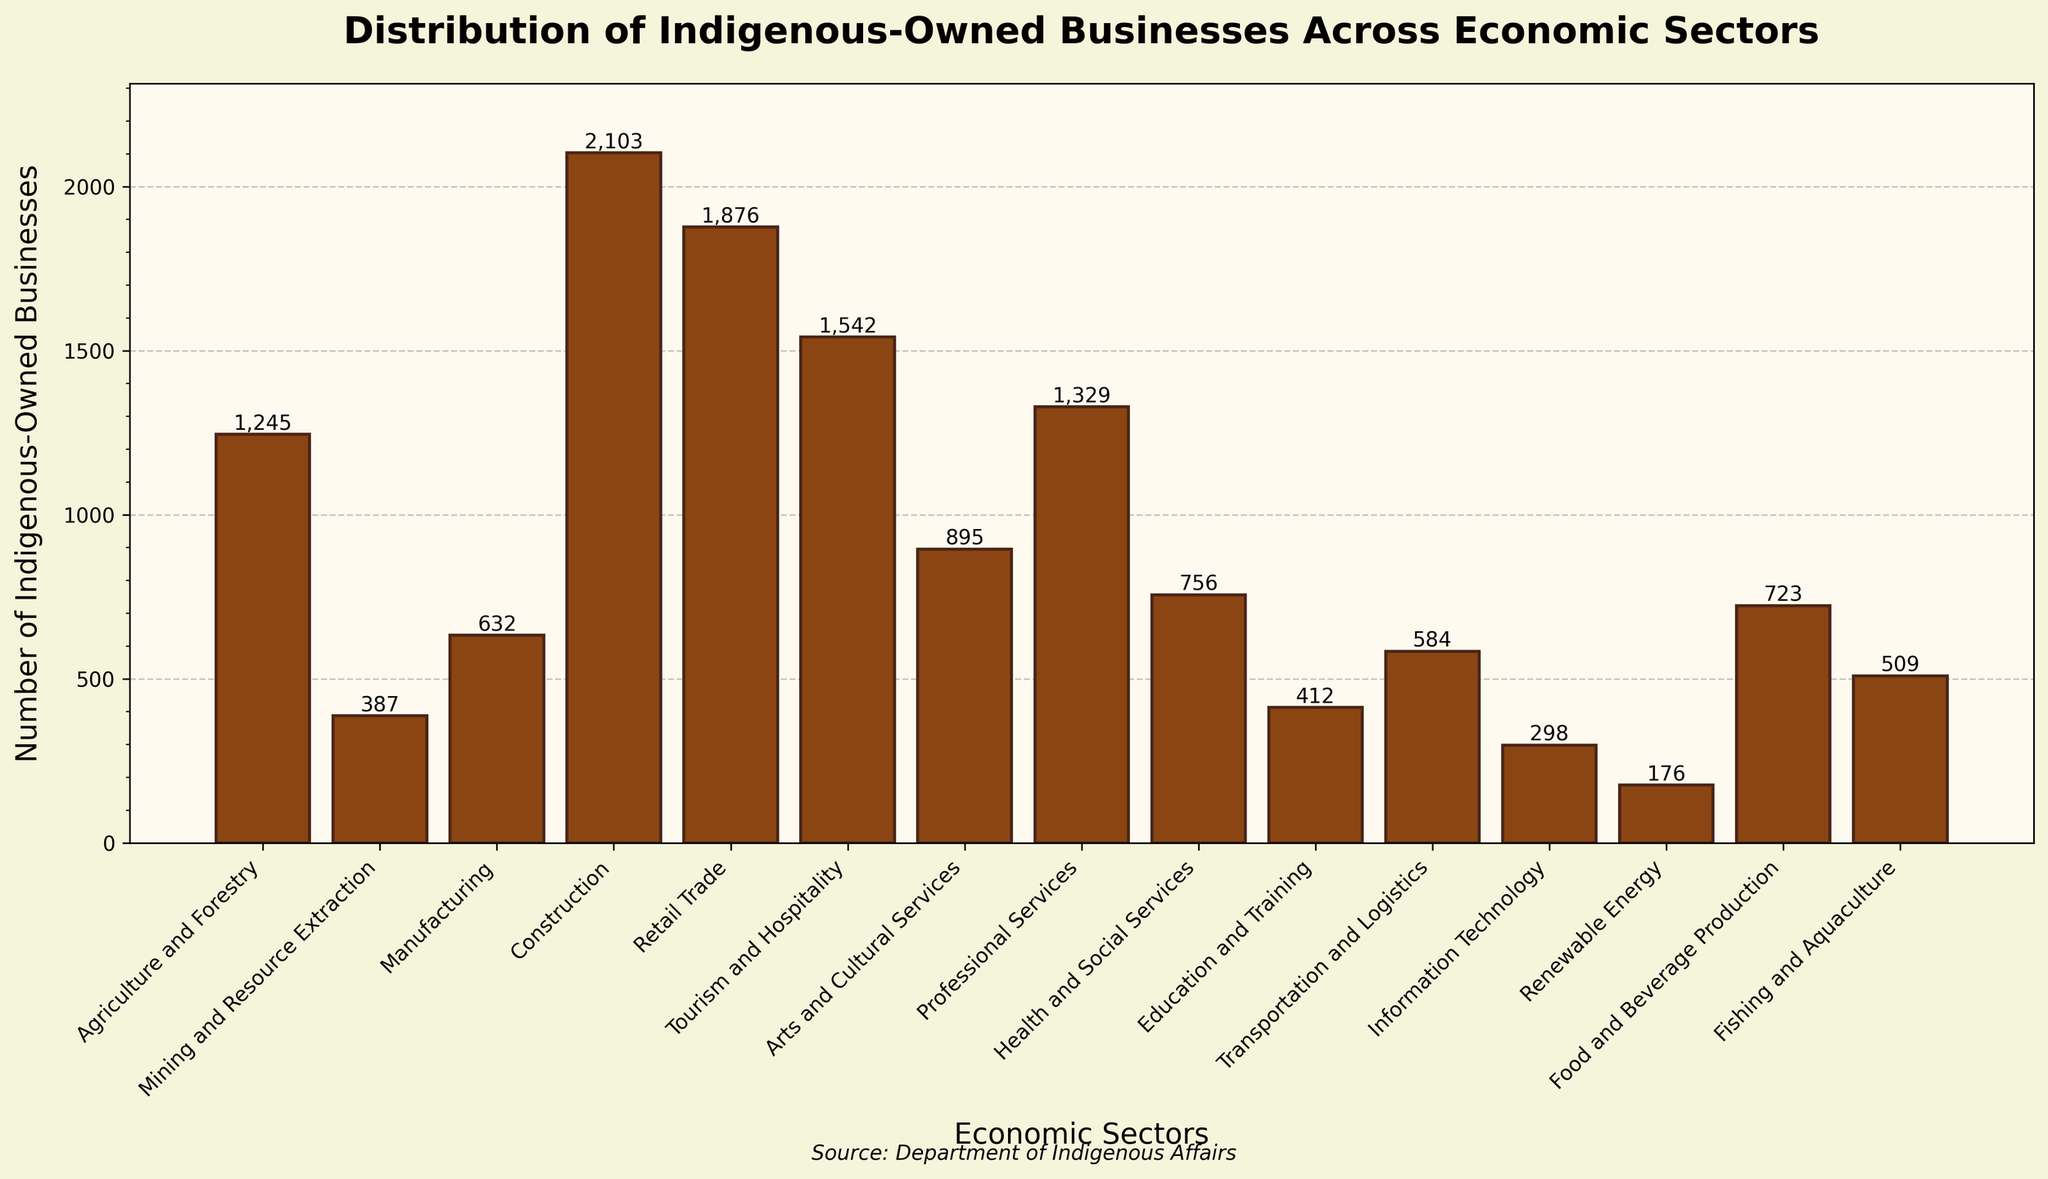What is the economic sector with the highest number of indigenous-owned businesses? The bar for the Construction sector is the tallest, indicating it has the highest number of indigenous-owned businesses.
Answer: Construction Which sector has fewer indigenous-owned businesses: Mining and Resource Extraction or Information Technology? The bar chart shows that Mining and Resource Extraction has 387 businesses, and Information Technology has 298 businesses, making the latter fewer in number.
Answer: Information Technology How many more indigenous-owned businesses are there in Construction than in Arts and Cultural Services? The number of businesses in Construction is 2103, and in Arts and Cultural Services is 895. Subtracting the two gives 2103 - 895 = 1208.
Answer: 1208 What is the combined total of indigenous-owned businesses in Agriculture and Forestry and Food and Beverage Production? Agriculture and Forestry has 1245 businesses, and Food and Beverage Production has 723. Adding these gives 1245 + 723 = 1968.
Answer: 1968 Which sector has nearly double the number of businesses as Fishing and Aquaculture? Fishing and Aquaculture has 509 businesses. Looking at the chart, Professional Services has 1329 businesses which is more than double of 509.
Answer: Professional Services What is the difference in the number of indigenous-owned businesses between Retail Trade and Health and Social Services? Retail Trade has 1876 businesses, and Health and Social Services has 756. Subtracting these gives 1876 - 756 = 1120.
Answer: 1120 How many sectors have more than 1000 indigenous-owned businesses? From the bar chart, the sectors with more than 1000 businesses are Agriculture and Forestry, Construction, Retail Trade, Tourism and Hospitality, and Professional Services, totaling 5 sectors.
Answer: 5 Which sector has a slightly higher number of businesses than Education and Training? Education and Training has 412 businesses, while Transportation and Logistics has 584, which is slightly higher.
Answer: Transportation and Logistics What is the average number of indigenous-owned businesses across the sectors of Renewable Energy, Information Technology, and Fishing and Aquaculture? Adding the number of businesses in Renewable Energy (176), Information Technology (298), and Fishing and Aquaculture (509) gives 176 + 298 + 509 = 983. Dividing by the number of sectors (3) gives 983 / 3 ≈ 328.
Answer: 328 Which has a greater difference in the number of indigenous-owned businesses: Tourism and Hospitality vs. Professional Services, or Professional Services vs. Arts and Cultural Services? The difference between Tourism and Hospitality (1542) and Professional Services (1329) is 1542 - 1329 = 213. The difference between Professional Services (1329) and Arts and Cultural Services (895) is 1329 - 895 = 434. Hence, the latter has a greater difference.
Answer: Professional Services vs. Arts and Cultural Services 